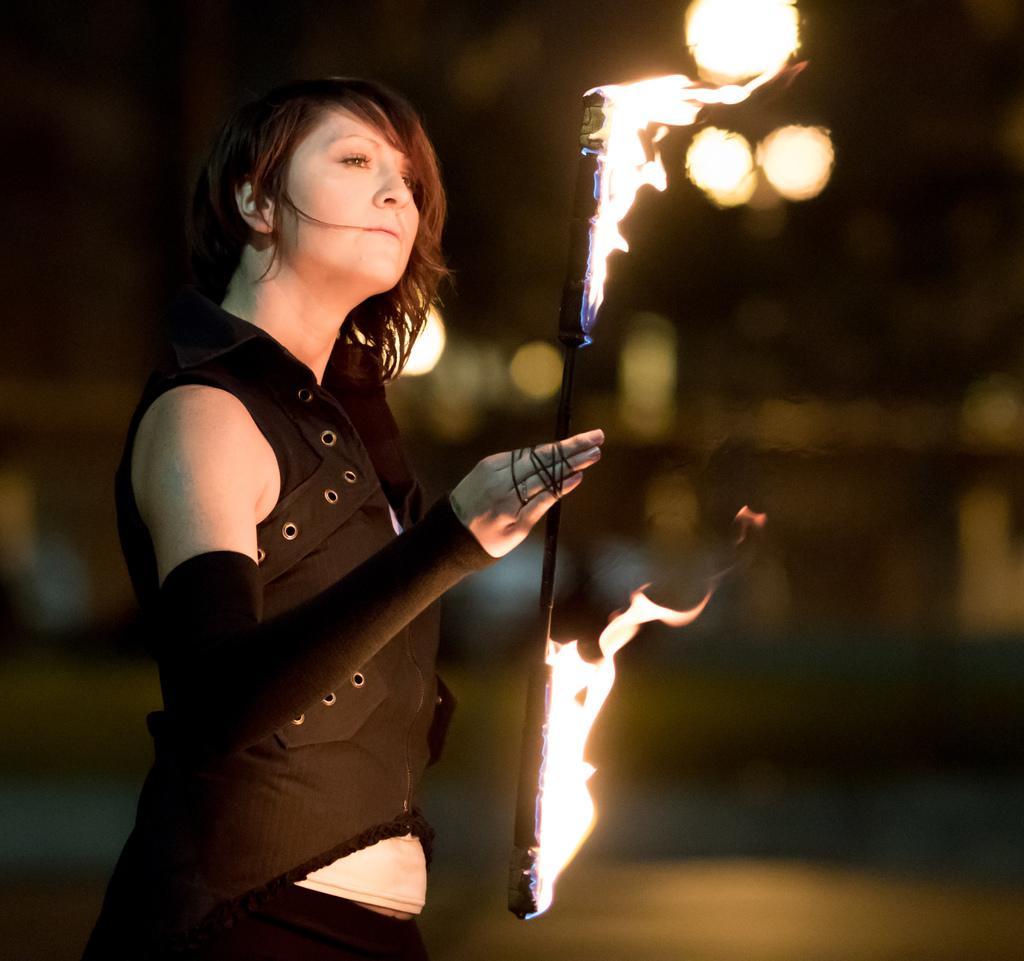How would you summarize this image in a sentence or two? In this image, I can see a person standing and holding a stick with fire. There is a blurred background. 